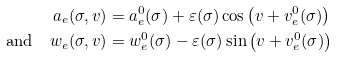<formula> <loc_0><loc_0><loc_500><loc_500>a _ { e } ( \sigma , v ) & = a ^ { 0 } _ { e } ( \sigma ) + \varepsilon ( \sigma ) \cos \left ( v + v ^ { 0 } _ { e } ( \sigma ) \right ) \\ \text {and} \quad w _ { e } ( \sigma , v ) & = w ^ { 0 } _ { e } ( \sigma ) - \varepsilon ( \sigma ) \sin \left ( v + v ^ { 0 } _ { e } ( \sigma ) \right )</formula> 